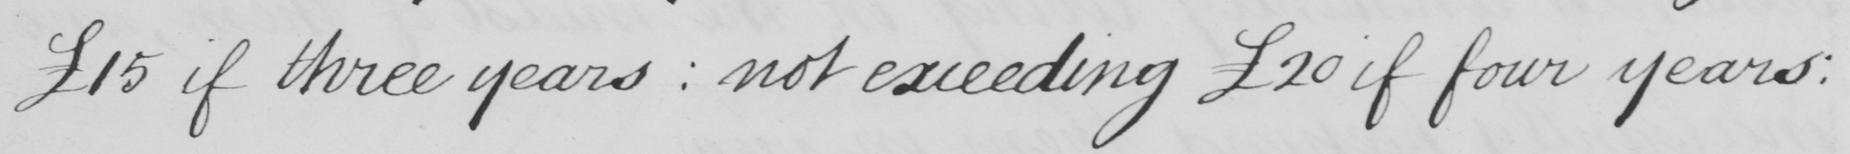What does this handwritten line say? £15 if three years :  not exceeding  £20 if four years : 